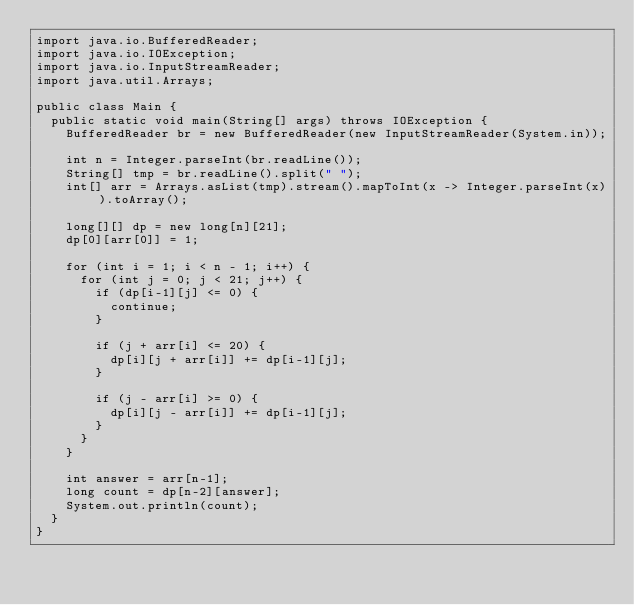Convert code to text. <code><loc_0><loc_0><loc_500><loc_500><_Java_>import java.io.BufferedReader;
import java.io.IOException;
import java.io.InputStreamReader;
import java.util.Arrays;

public class Main {
  public static void main(String[] args) throws IOException {
    BufferedReader br = new BufferedReader(new InputStreamReader(System.in));

    int n = Integer.parseInt(br.readLine());
    String[] tmp = br.readLine().split(" ");
    int[] arr = Arrays.asList(tmp).stream().mapToInt(x -> Integer.parseInt(x)).toArray();

    long[][] dp = new long[n][21];
    dp[0][arr[0]] = 1;

    for (int i = 1; i < n - 1; i++) {
      for (int j = 0; j < 21; j++) {
        if (dp[i-1][j] <= 0) {
          continue;
        }

        if (j + arr[i] <= 20) {
          dp[i][j + arr[i]] += dp[i-1][j];
        }

        if (j - arr[i] >= 0) {
          dp[i][j - arr[i]] += dp[i-1][j];
        }
      }
    }

    int answer = arr[n-1];
    long count = dp[n-2][answer];
    System.out.println(count);
  }
}</code> 